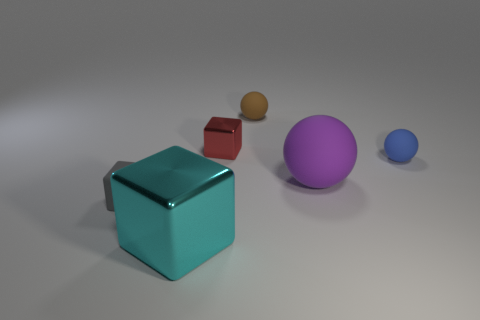There is a shiny cube left of the red shiny block; what is its size?
Offer a very short reply. Large. There is a metallic object that is in front of the shiny cube that is behind the blue sphere; what is its size?
Make the answer very short. Large. Are there more brown rubber objects than tiny yellow balls?
Make the answer very short. Yes. Is the number of objects that are behind the small gray rubber object greater than the number of matte objects that are to the left of the tiny brown matte sphere?
Provide a short and direct response. Yes. What size is the object that is both on the right side of the red metallic cube and behind the blue sphere?
Your answer should be compact. Small. What number of brown rubber spheres have the same size as the blue thing?
Offer a very short reply. 1. Is the shape of the object that is on the left side of the big cyan block the same as  the brown rubber thing?
Offer a terse response. No. Are there fewer large purple balls to the right of the purple matte thing than big green metallic cubes?
Offer a terse response. No. There is a blue matte thing; is its shape the same as the big thing right of the brown matte sphere?
Make the answer very short. Yes. Is there a tiny blue ball that has the same material as the tiny brown thing?
Offer a terse response. Yes. 